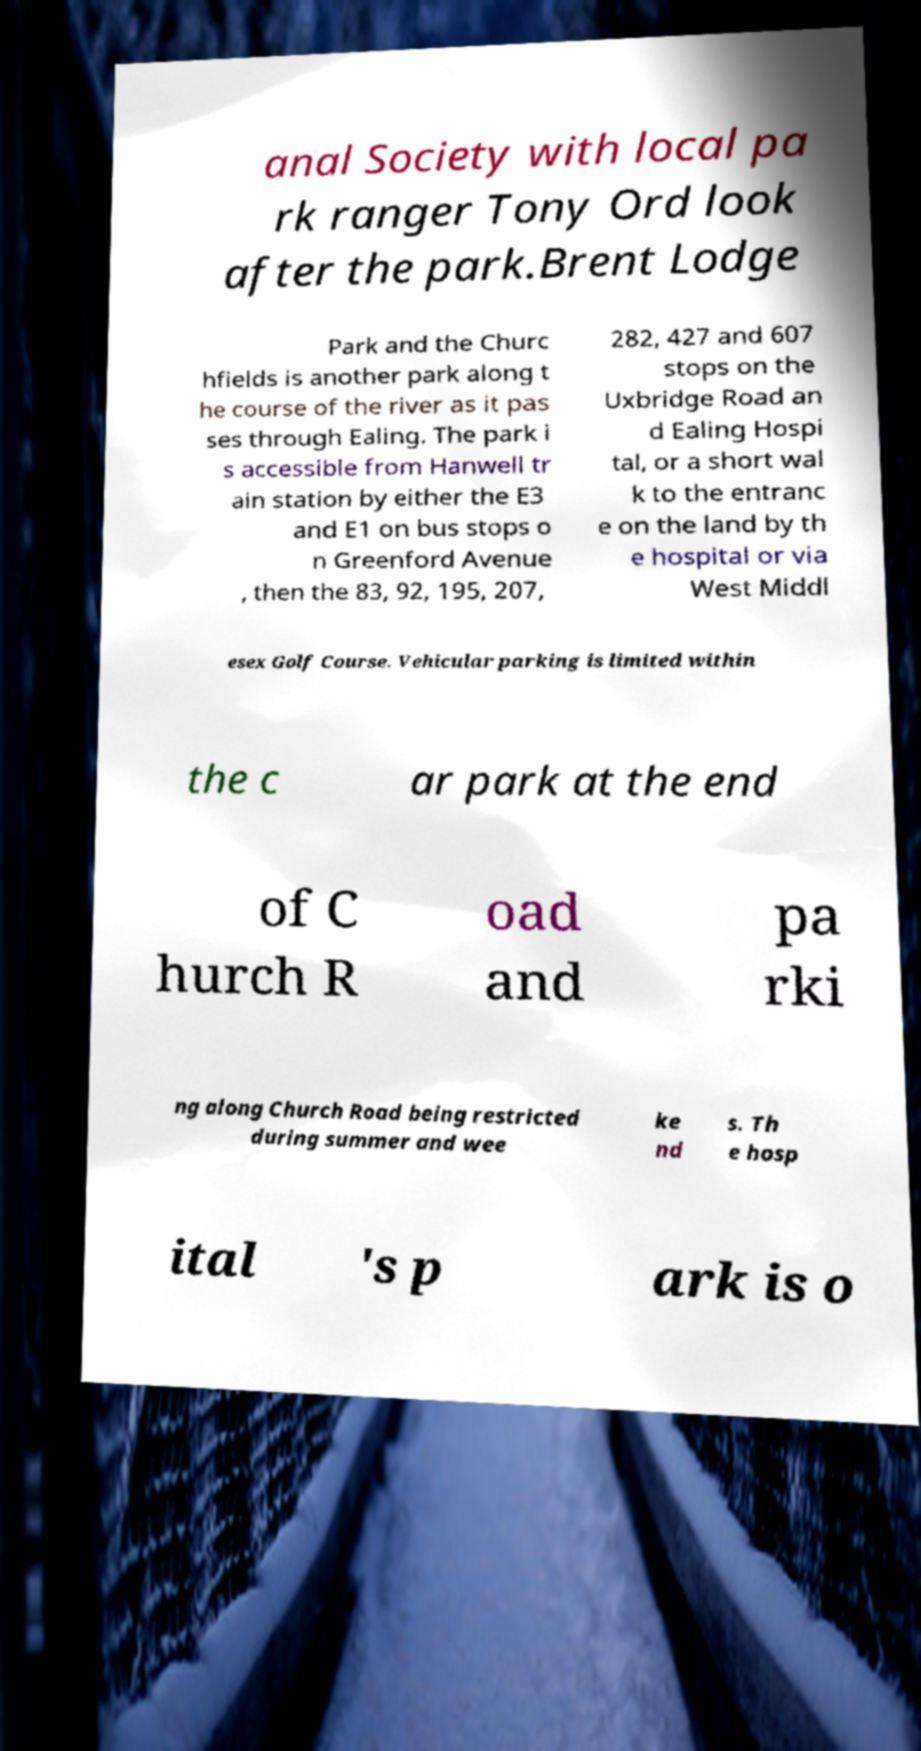Could you assist in decoding the text presented in this image and type it out clearly? anal Society with local pa rk ranger Tony Ord look after the park.Brent Lodge Park and the Churc hfields is another park along t he course of the river as it pas ses through Ealing. The park i s accessible from Hanwell tr ain station by either the E3 and E1 on bus stops o n Greenford Avenue , then the 83, 92, 195, 207, 282, 427 and 607 stops on the Uxbridge Road an d Ealing Hospi tal, or a short wal k to the entranc e on the land by th e hospital or via West Middl esex Golf Course. Vehicular parking is limited within the c ar park at the end of C hurch R oad and pa rki ng along Church Road being restricted during summer and wee ke nd s. Th e hosp ital 's p ark is o 